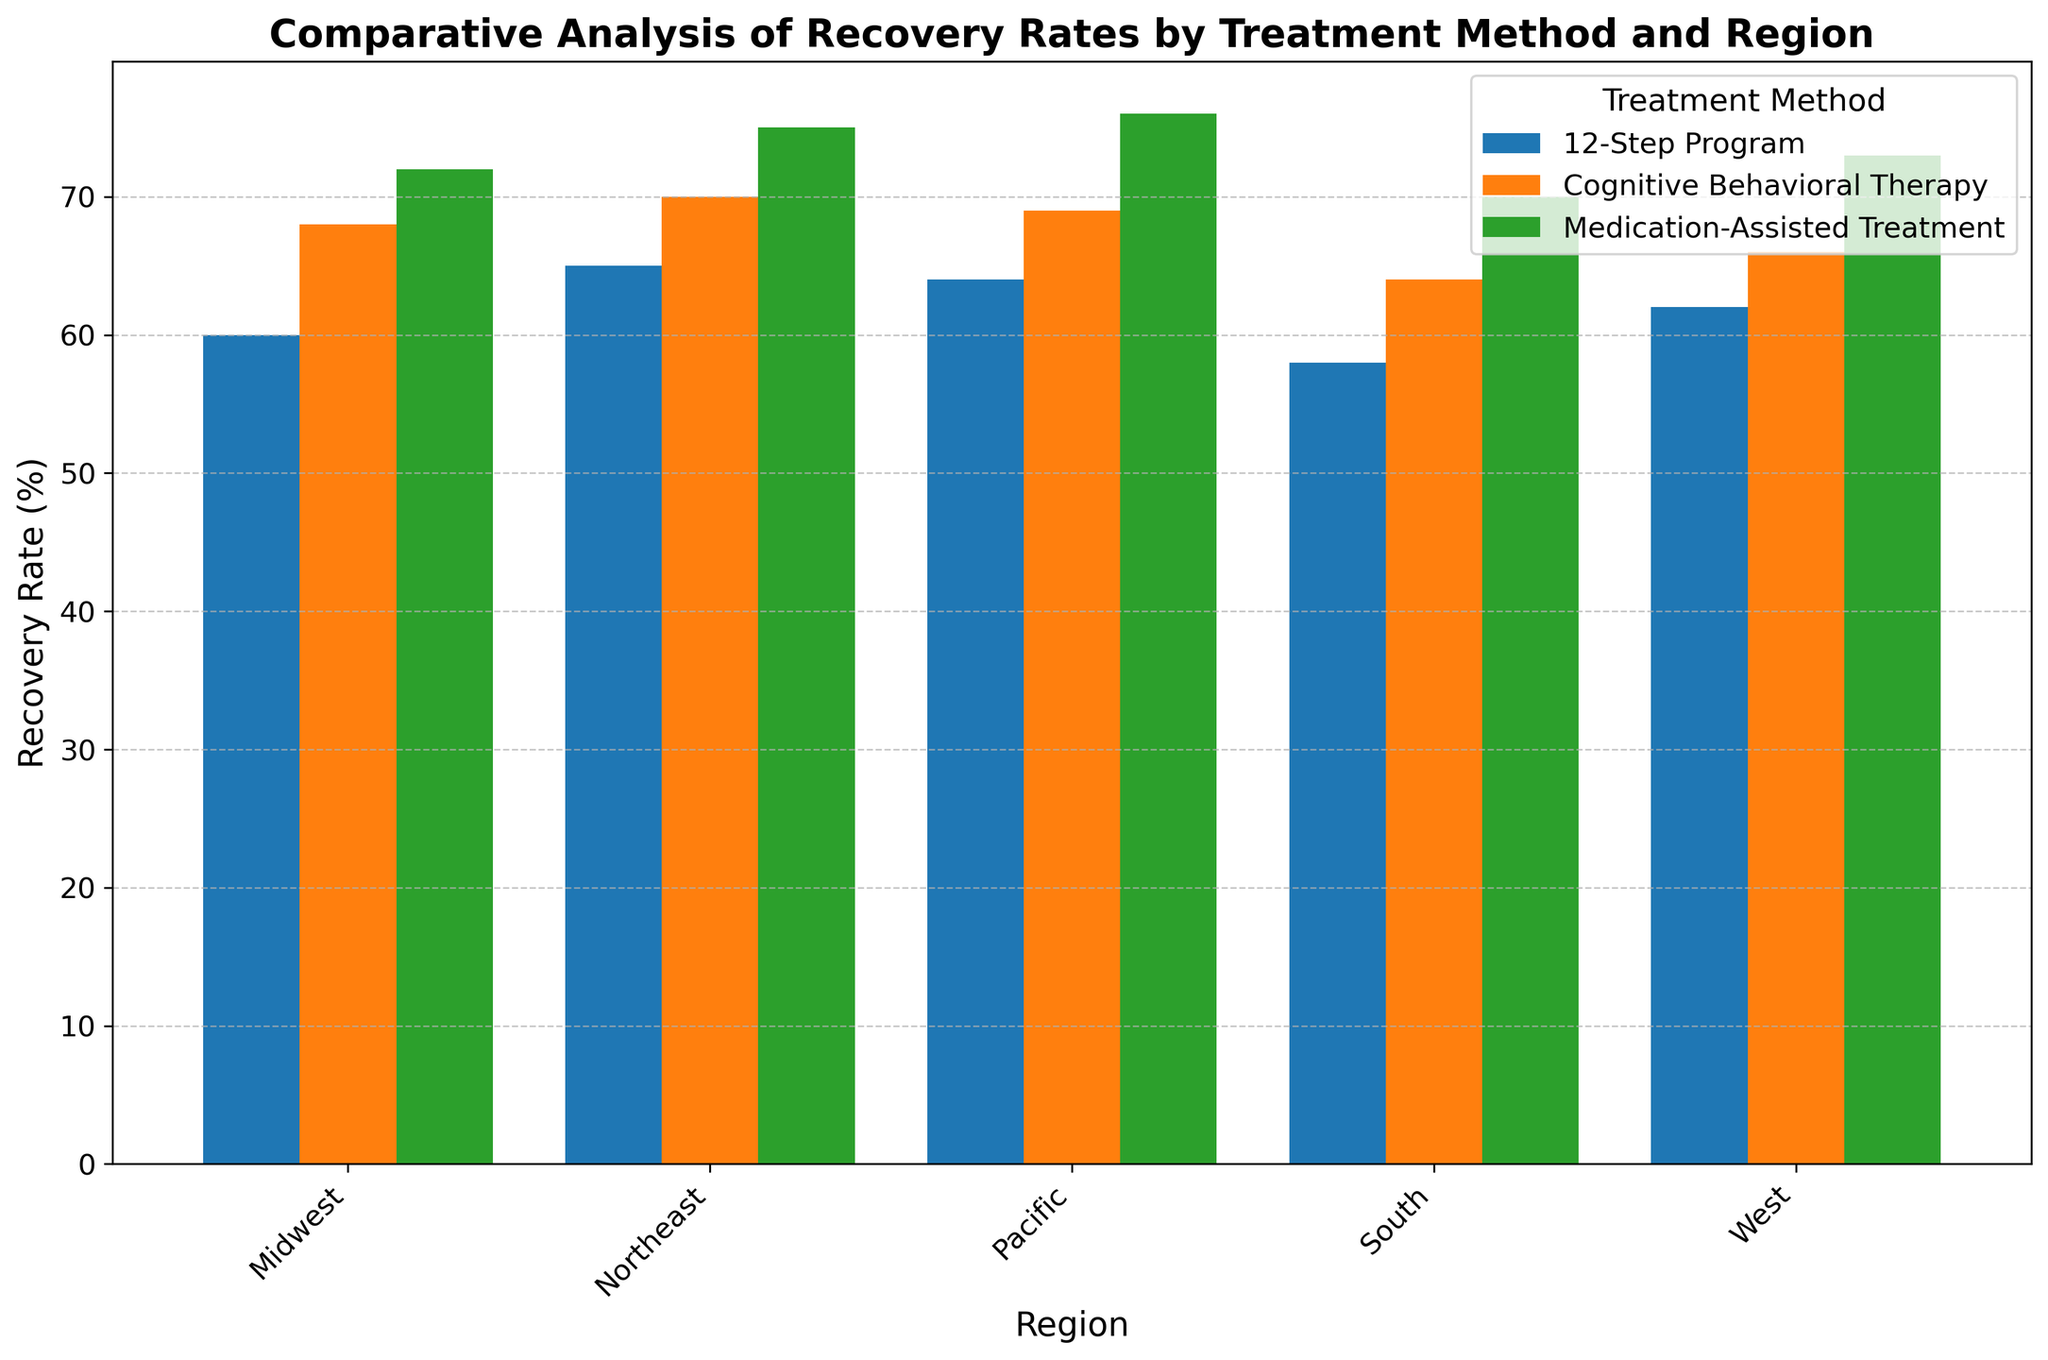Which region has the highest recovery rate for Medication-Assisted Treatment? The bar for the Pacific region is the tallest among all regions for Medication-Assisted Treatment, indicating the highest recovery rate.
Answer: Pacific How much higher is the recovery rate for Cognitive Behavioral Therapy compared to the 12-Step Program in the Northeast? The recovery rate for Cognitive Behavioral Therapy in the Northeast is 70%, while for the 12-Step Program, it is 65%. The difference is 70 - 65 = 5%.
Answer: 5% Which treatment method has the lowest average recovery rate across all regions? First, find the recovery rates for each treatment method across all regions: 12-Step Program (65+60+58+62+64)/5 = 61.8, Cognitive Behavioral Therapy (70+68+64+66+69)/5 = 67.4, and Medication-Assisted Treatment (75+72+70+73+76)/5 = 73.2. The 12-Step Program has the lowest average recovery rate.
Answer: 12-Step Program Is the recovery rate for Medication-Assisted Treatment always higher than that for the 12-Step Program across all regions? By comparing the bars for Medication-Assisted Treatment and the 12-Step Program in each region: Northeast (75 vs. 65), Midwest (72 vs. 60), South (70 vs. 58), West (73 vs. 62), Pacific (76 vs. 64), the recovery rate for Medication-Assisted Treatment is always higher.
Answer: Yes What is the total recovery rate for Cognitive Behavioral Therapy across the Midwest and South regions combined? The recovery rate for Cognitive Behavioral Therapy in the Midwest is 68%, and in the South, it is 64%. The total is 68 + 64 = 132%.
Answer: 132% Which region has the most consistent recovery rates across all treatment methods? Comparing the differences in recovery rates within each region: Northeast (75-65 = 10), Midwest (72-60 = 12), South (70-58 = 12), West (73-62 = 11), Pacific (76-64 = 12), the Northeast has the smallest range of recovery rates (10), indicating the most consistency.
Answer: Northeast Which treatment method shows the greatest variation in recovery rates across the regions? Calculate the range for each treatment method: 12-Step Program (65-58 = 7), Cognitive Behavioral Therapy (70-64 = 6), Medication-Assisted Treatment (76-70 = 6). The 12-Step Program shows the greatest variation.
Answer: 12-Step Program If you sum up the recovery rates for all treatment methods in the West region, what is the total? Recovery rates in the West region: 12-Step Program (62), Cognitive Behavioral Therapy (66), Medication-Assisted Treatment (73). Total = 62 + 66 + 73 = 201%.
Answer: 201% In which region is the gap between the highest and lowest recovery rate the smallest? Calculate the gap for each region: Northeast (75-65 = 10), Midwest (72-60 = 12), South (70-58 = 12), West (73-62 = 11), Pacific (76-64 = 12). The Northeast has the smallest gap (10).
Answer: Northeast 